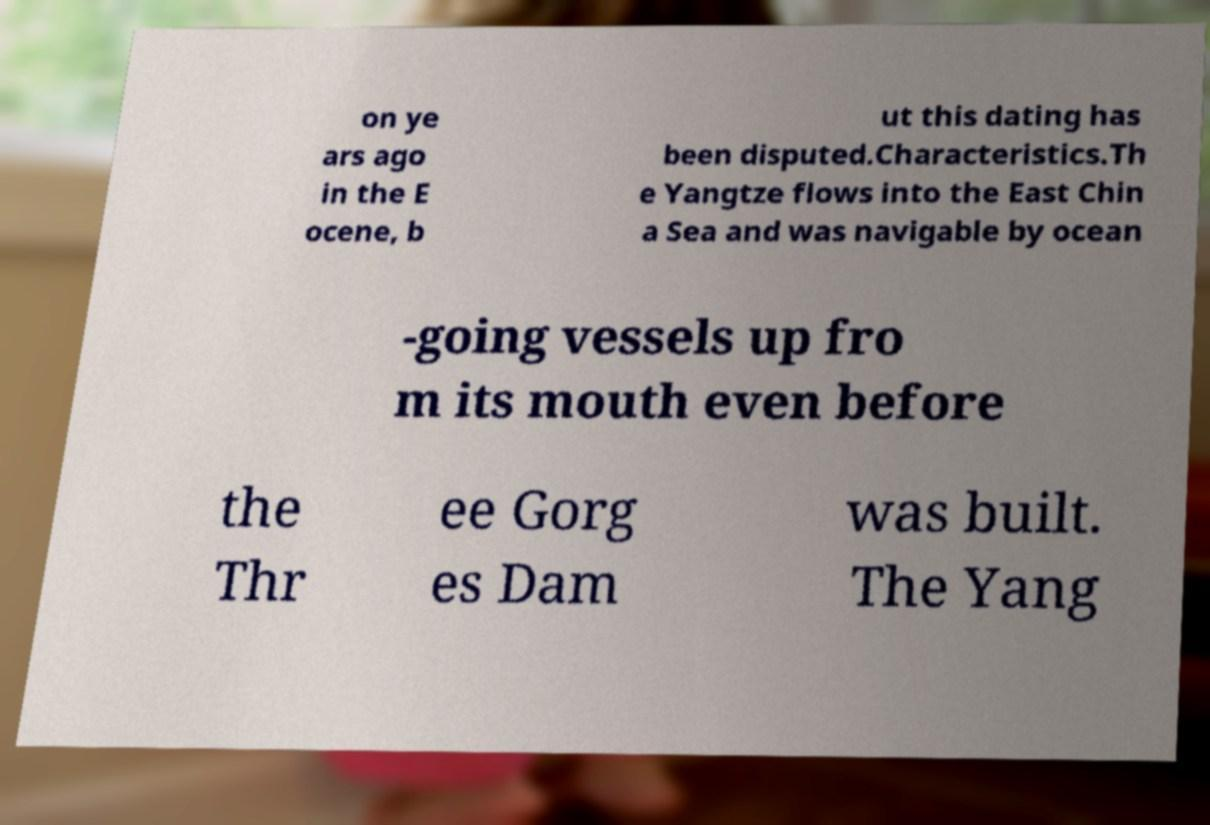Can you accurately transcribe the text from the provided image for me? on ye ars ago in the E ocene, b ut this dating has been disputed.Characteristics.Th e Yangtze flows into the East Chin a Sea and was navigable by ocean -going vessels up fro m its mouth even before the Thr ee Gorg es Dam was built. The Yang 